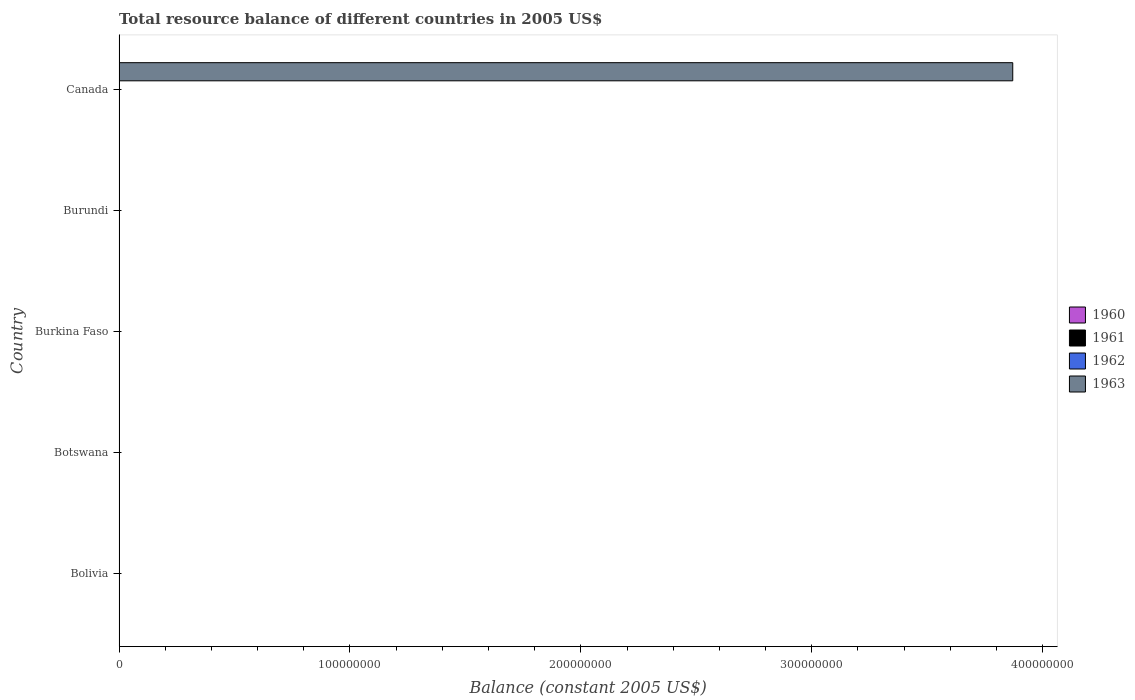How many different coloured bars are there?
Give a very brief answer. 1. Are the number of bars on each tick of the Y-axis equal?
Your answer should be very brief. No. How many bars are there on the 3rd tick from the top?
Offer a terse response. 0. What is the label of the 3rd group of bars from the top?
Give a very brief answer. Burkina Faso. Across all countries, what is the maximum total resource balance in 1963?
Keep it short and to the point. 3.87e+08. What is the average total resource balance in 1961 per country?
Make the answer very short. 0. In how many countries, is the total resource balance in 1961 greater than 360000000 US$?
Offer a terse response. 0. What is the difference between the highest and the lowest total resource balance in 1963?
Provide a short and direct response. 3.87e+08. Is it the case that in every country, the sum of the total resource balance in 1962 and total resource balance in 1961 is greater than the sum of total resource balance in 1960 and total resource balance in 1963?
Your answer should be compact. No. How many countries are there in the graph?
Your answer should be very brief. 5. Does the graph contain any zero values?
Provide a succinct answer. Yes. Where does the legend appear in the graph?
Keep it short and to the point. Center right. How are the legend labels stacked?
Give a very brief answer. Vertical. What is the title of the graph?
Ensure brevity in your answer.  Total resource balance of different countries in 2005 US$. What is the label or title of the X-axis?
Provide a short and direct response. Balance (constant 2005 US$). What is the Balance (constant 2005 US$) in 1960 in Bolivia?
Provide a succinct answer. 0. What is the Balance (constant 2005 US$) of 1961 in Bolivia?
Offer a very short reply. 0. What is the Balance (constant 2005 US$) in 1963 in Bolivia?
Provide a succinct answer. 0. What is the Balance (constant 2005 US$) in 1961 in Botswana?
Ensure brevity in your answer.  0. What is the Balance (constant 2005 US$) in 1962 in Botswana?
Offer a terse response. 0. What is the Balance (constant 2005 US$) in 1963 in Botswana?
Your response must be concise. 0. What is the Balance (constant 2005 US$) in 1961 in Burkina Faso?
Your answer should be very brief. 0. What is the Balance (constant 2005 US$) in 1962 in Burkina Faso?
Offer a very short reply. 0. What is the Balance (constant 2005 US$) of 1960 in Canada?
Give a very brief answer. 0. What is the Balance (constant 2005 US$) of 1962 in Canada?
Your response must be concise. 0. What is the Balance (constant 2005 US$) in 1963 in Canada?
Offer a terse response. 3.87e+08. Across all countries, what is the maximum Balance (constant 2005 US$) in 1963?
Your answer should be very brief. 3.87e+08. What is the total Balance (constant 2005 US$) in 1960 in the graph?
Offer a very short reply. 0. What is the total Balance (constant 2005 US$) in 1963 in the graph?
Your answer should be compact. 3.87e+08. What is the average Balance (constant 2005 US$) in 1963 per country?
Offer a terse response. 7.74e+07. What is the difference between the highest and the lowest Balance (constant 2005 US$) of 1963?
Your answer should be compact. 3.87e+08. 